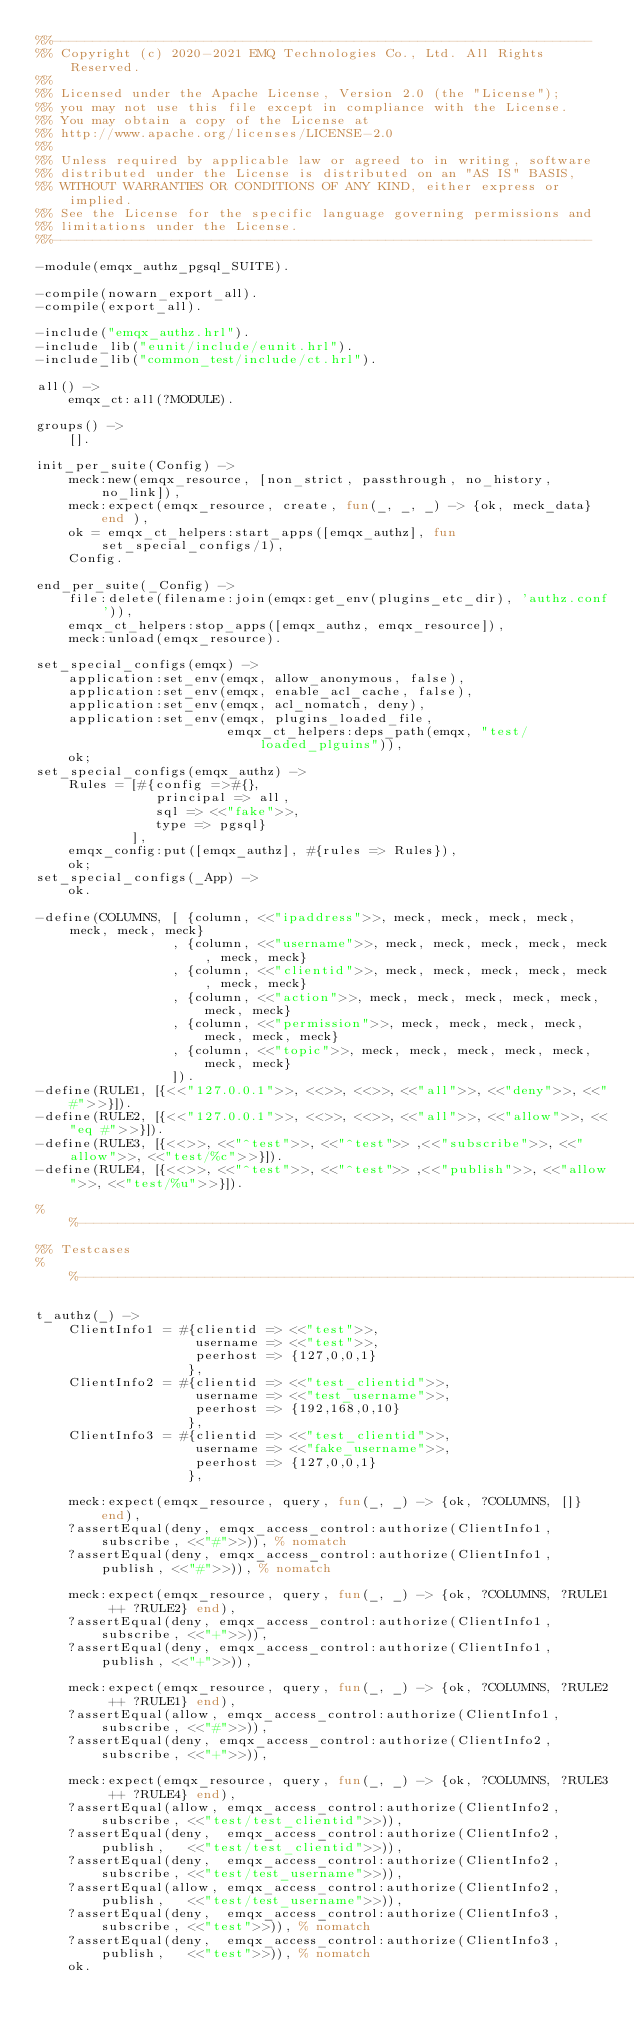Convert code to text. <code><loc_0><loc_0><loc_500><loc_500><_Erlang_>%%--------------------------------------------------------------------
%% Copyright (c) 2020-2021 EMQ Technologies Co., Ltd. All Rights Reserved.
%%
%% Licensed under the Apache License, Version 2.0 (the "License");
%% you may not use this file except in compliance with the License.
%% You may obtain a copy of the License at
%% http://www.apache.org/licenses/LICENSE-2.0
%%
%% Unless required by applicable law or agreed to in writing, software
%% distributed under the License is distributed on an "AS IS" BASIS,
%% WITHOUT WARRANTIES OR CONDITIONS OF ANY KIND, either express or implied.
%% See the License for the specific language governing permissions and
%% limitations under the License.
%%--------------------------------------------------------------------

-module(emqx_authz_pgsql_SUITE).

-compile(nowarn_export_all).
-compile(export_all).

-include("emqx_authz.hrl").
-include_lib("eunit/include/eunit.hrl").
-include_lib("common_test/include/ct.hrl").

all() ->
    emqx_ct:all(?MODULE).

groups() ->
    [].

init_per_suite(Config) ->
    meck:new(emqx_resource, [non_strict, passthrough, no_history, no_link]),
    meck:expect(emqx_resource, create, fun(_, _, _) -> {ok, meck_data} end ),
    ok = emqx_ct_helpers:start_apps([emqx_authz], fun set_special_configs/1),
    Config.

end_per_suite(_Config) ->
    file:delete(filename:join(emqx:get_env(plugins_etc_dir), 'authz.conf')),
    emqx_ct_helpers:stop_apps([emqx_authz, emqx_resource]),
    meck:unload(emqx_resource).

set_special_configs(emqx) ->
    application:set_env(emqx, allow_anonymous, false),
    application:set_env(emqx, enable_acl_cache, false),
    application:set_env(emqx, acl_nomatch, deny),
    application:set_env(emqx, plugins_loaded_file,
                        emqx_ct_helpers:deps_path(emqx, "test/loaded_plguins")),
    ok;
set_special_configs(emqx_authz) ->
    Rules = [#{config =>#{},
               principal => all,
               sql => <<"fake">>,
               type => pgsql}
            ],
    emqx_config:put([emqx_authz], #{rules => Rules}),
    ok;
set_special_configs(_App) ->
    ok.

-define(COLUMNS, [ {column, <<"ipaddress">>, meck, meck, meck, meck, meck, meck, meck}
                 , {column, <<"username">>, meck, meck, meck, meck, meck, meck, meck}
                 , {column, <<"clientid">>, meck, meck, meck, meck, meck, meck, meck}
                 , {column, <<"action">>, meck, meck, meck, meck, meck, meck, meck}
                 , {column, <<"permission">>, meck, meck, meck, meck, meck, meck, meck}
                 , {column, <<"topic">>, meck, meck, meck, meck, meck, meck, meck}
                 ]).
-define(RULE1, [{<<"127.0.0.1">>, <<>>, <<>>, <<"all">>, <<"deny">>, <<"#">>}]).
-define(RULE2, [{<<"127.0.0.1">>, <<>>, <<>>, <<"all">>, <<"allow">>, <<"eq #">>}]).
-define(RULE3, [{<<>>, <<"^test">>, <<"^test">> ,<<"subscribe">>, <<"allow">>, <<"test/%c">>}]).
-define(RULE4, [{<<>>, <<"^test">>, <<"^test">> ,<<"publish">>, <<"allow">>, <<"test/%u">>}]).

%%------------------------------------------------------------------------------
%% Testcases
%%------------------------------------------------------------------------------

t_authz(_) ->
    ClientInfo1 = #{clientid => <<"test">>,
                    username => <<"test">>,
                    peerhost => {127,0,0,1}
                   },
    ClientInfo2 = #{clientid => <<"test_clientid">>,
                    username => <<"test_username">>,
                    peerhost => {192,168,0,10}
                   },
    ClientInfo3 = #{clientid => <<"test_clientid">>,
                    username => <<"fake_username">>,
                    peerhost => {127,0,0,1}
                   },

    meck:expect(emqx_resource, query, fun(_, _) -> {ok, ?COLUMNS, []} end),
    ?assertEqual(deny, emqx_access_control:authorize(ClientInfo1, subscribe, <<"#">>)), % nomatch
    ?assertEqual(deny, emqx_access_control:authorize(ClientInfo1, publish, <<"#">>)), % nomatch

    meck:expect(emqx_resource, query, fun(_, _) -> {ok, ?COLUMNS, ?RULE1 ++ ?RULE2} end),
    ?assertEqual(deny, emqx_access_control:authorize(ClientInfo1, subscribe, <<"+">>)),
    ?assertEqual(deny, emqx_access_control:authorize(ClientInfo1, publish, <<"+">>)),

    meck:expect(emqx_resource, query, fun(_, _) -> {ok, ?COLUMNS, ?RULE2 ++ ?RULE1} end),
    ?assertEqual(allow, emqx_access_control:authorize(ClientInfo1, subscribe, <<"#">>)),
    ?assertEqual(deny, emqx_access_control:authorize(ClientInfo2, subscribe, <<"+">>)),

    meck:expect(emqx_resource, query, fun(_, _) -> {ok, ?COLUMNS, ?RULE3 ++ ?RULE4} end),
    ?assertEqual(allow, emqx_access_control:authorize(ClientInfo2, subscribe, <<"test/test_clientid">>)),
    ?assertEqual(deny,  emqx_access_control:authorize(ClientInfo2, publish,   <<"test/test_clientid">>)),
    ?assertEqual(deny,  emqx_access_control:authorize(ClientInfo2, subscribe, <<"test/test_username">>)),
    ?assertEqual(allow, emqx_access_control:authorize(ClientInfo2, publish,   <<"test/test_username">>)),
    ?assertEqual(deny,  emqx_access_control:authorize(ClientInfo3, subscribe, <<"test">>)), % nomatch
    ?assertEqual(deny,  emqx_access_control:authorize(ClientInfo3, publish,   <<"test">>)), % nomatch
    ok.

</code> 